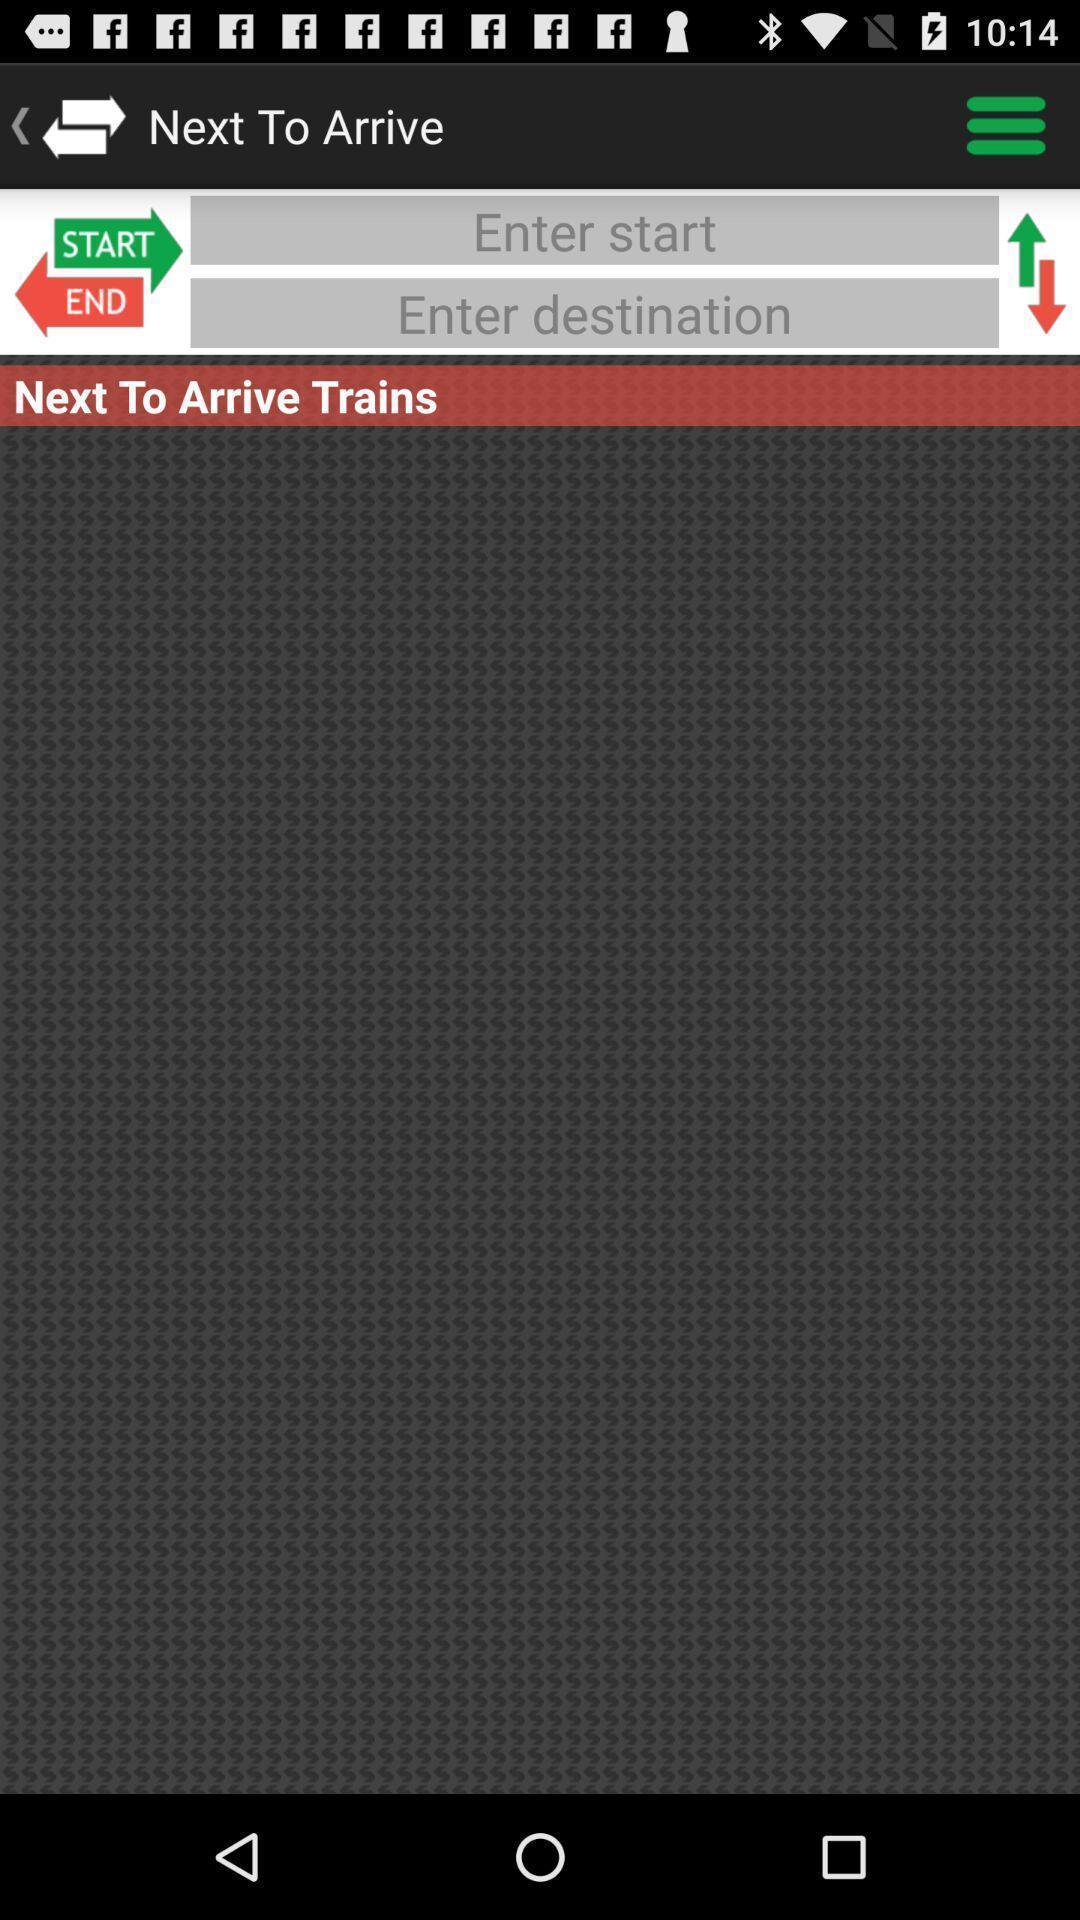What can you discern from this picture? Screen showing options to choose destination in travel app. 